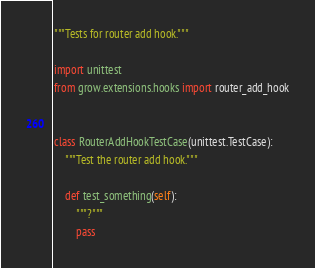Convert code to text. <code><loc_0><loc_0><loc_500><loc_500><_Python_>"""Tests for router add hook."""

import unittest
from grow.extensions.hooks import router_add_hook


class RouterAddHookTestCase(unittest.TestCase):
    """Test the router add hook."""

    def test_something(self):
        """?"""
        pass
</code> 